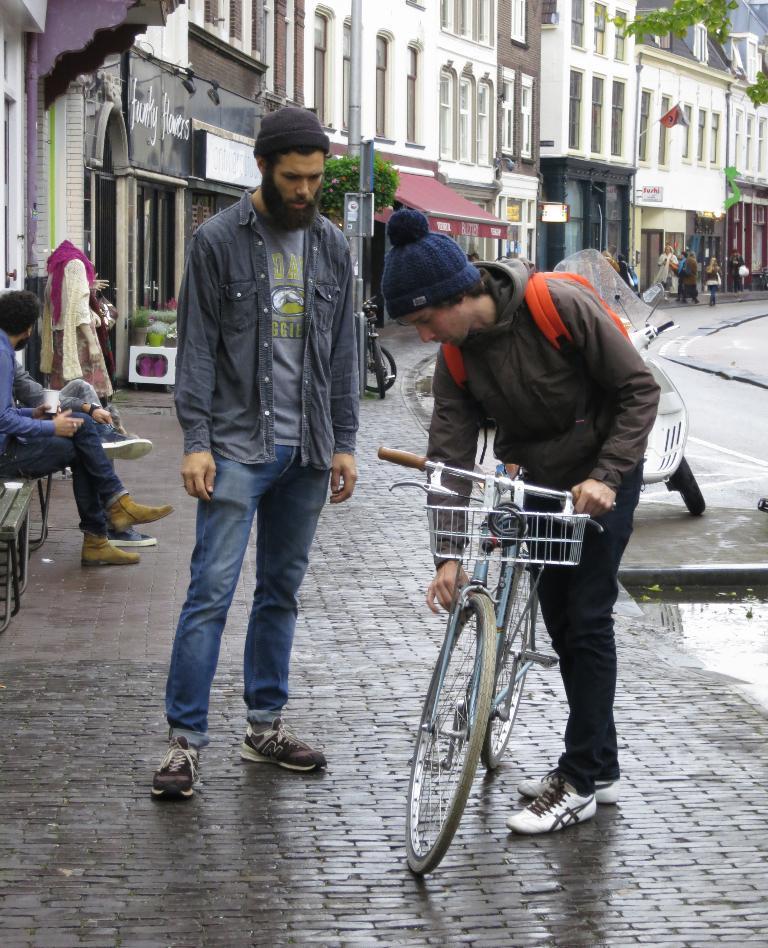Describe this image in one or two sentences. In the middle of the image a man is standing and holding a bicycle. Behind him there are some bicycles and motorcycles and few people are standing and sitting. In the middle of the image there are some poles and trees and plants. At the top of the image there are some buildings. 